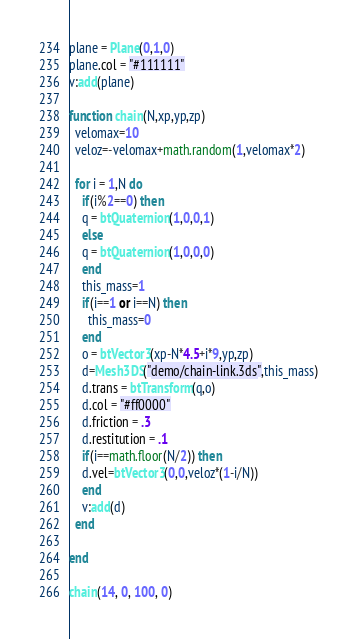<code> <loc_0><loc_0><loc_500><loc_500><_Lua_>plane = Plane(0,1,0)
plane.col = "#111111"
v:add(plane)

function chain(N,xp,yp,zp)
  velomax=10
  veloz=-velomax+math.random(1,velomax*2)

  for i = 1,N do
    if(i%2==0) then
    q = btQuaternion(1,0,0,1)
    else
    q = btQuaternion(1,0,0,0)
    end
    this_mass=1
    if(i==1 or i==N) then 
      this_mass=0
    end
    o = btVector3(xp-N*4.5+i*9,yp,zp)
    d=Mesh3DS("demo/chain-link.3ds",this_mass)
    d.trans = btTransform(q,o)    
    d.col = "#ff0000"
    d.friction = .3
    d.restitution = .1
    if(i==math.floor(N/2)) then
    d.vel=btVector3(0,0,veloz*(1-i/N))
    end
    v:add(d)
  end
    
end

chain(14, 0, 100, 0)
</code> 